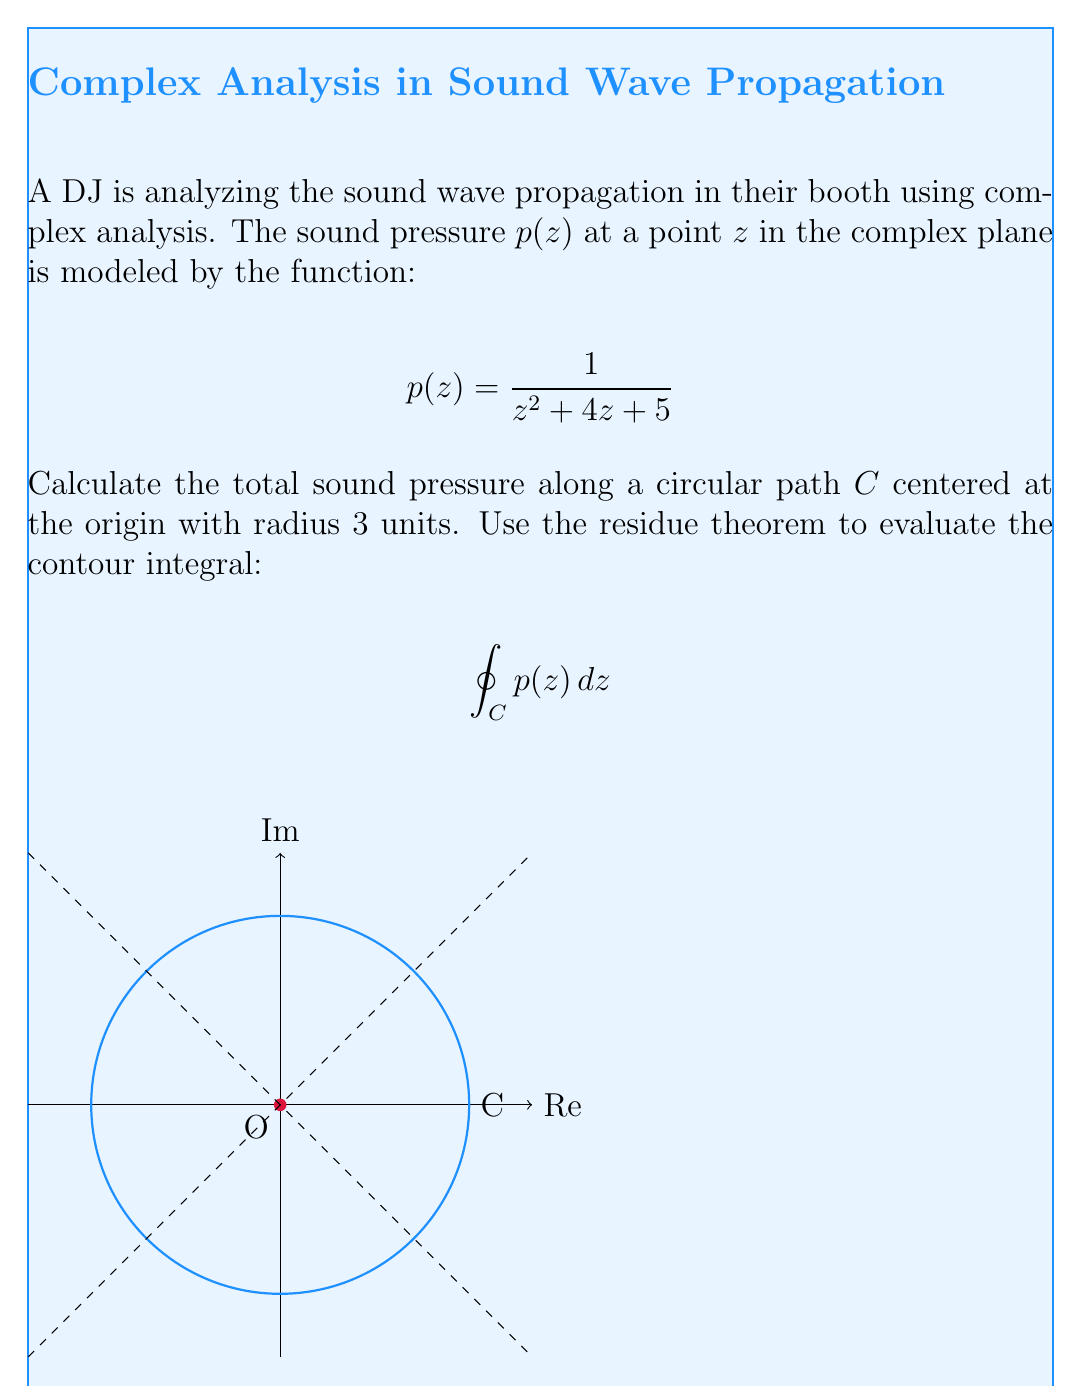Give your solution to this math problem. Let's approach this step-by-step:

1) First, we need to find the poles of $p(z)$ inside the contour $C$. The denominator of $p(z)$ is $z^2 + 4z + 5 = (z+2)^2 + 1$.

2) Solving $(z+2)^2 + 1 = 0$, we get $z = -2 \pm i$.

3) Only $z = -2 + i$ lies inside the contour $C$ (radius 3).

4) The residue theorem states:

   $$\oint_C p(z) dz = 2\pi i \sum \text{Res}(p, a_k)$$

   where $a_k$ are the poles inside $C$.

5) To find the residue at $z = -2 + i$, we use:

   $$\text{Res}(p, -2+i) = \lim_{z \to -2+i} (z-(-2+i))p(z)$$

6) Simplifying:

   $$\text{Res}(p, -2+i) = \lim_{z \to -2+i} \frac{z-(-2+i)}{z^2 + 4z + 5}$$

7) Using L'Hôpital's rule:

   $$\text{Res}(p, -2+i) = \lim_{z \to -2+i} \frac{1}{2z + 4} = \frac{1}{2(-2+i) + 4} = \frac{1}{2i} = -\frac{i}{2}$$

8) Applying the residue theorem:

   $$\oint_C p(z) dz = 2\pi i \cdot (-\frac{i}{2}) = \pi$$
Answer: $\pi$ 